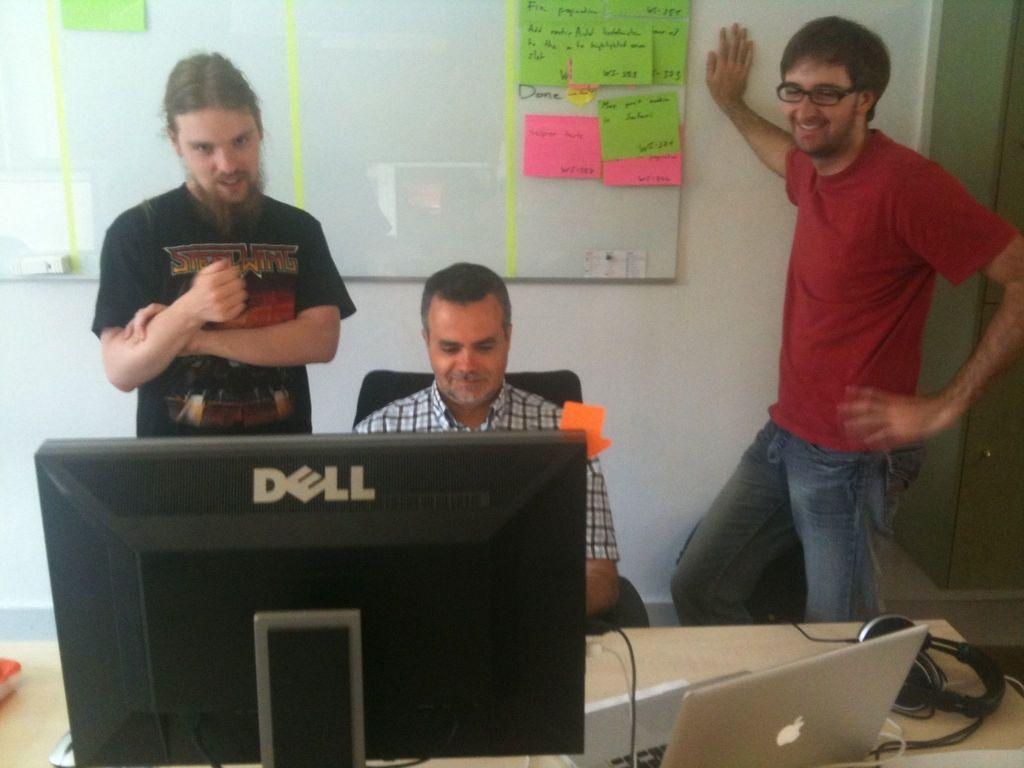How many men are present in the image? There are two men standing and one man sitting in the image. What is the sitting man interacting with? The sitting man is interacting with a monitor and a laptop in front of him. What type of audio equipment is on the table in the image? A: There are headphones on the table in the image. What color crayon is the sitting man using in the image? There are no crayons present in the image; the sitting man is interacting with a monitor and a laptop. 